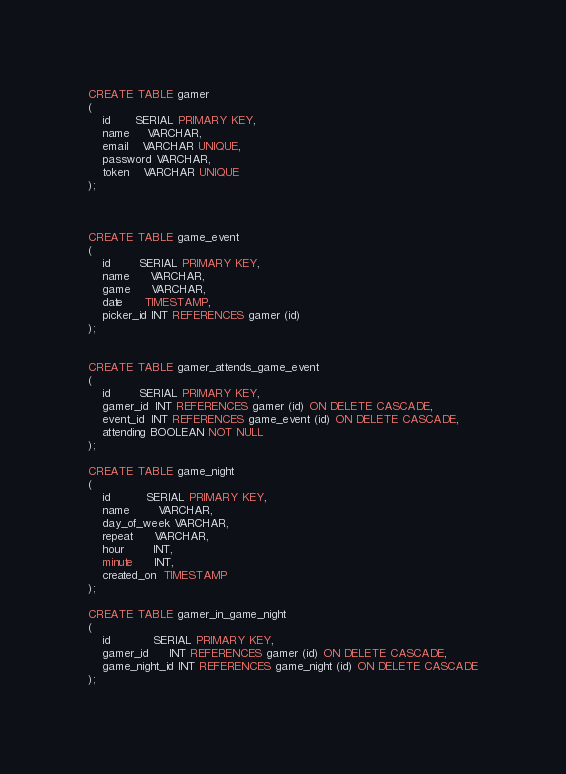<code> <loc_0><loc_0><loc_500><loc_500><_SQL_>CREATE TABLE gamer
(
    id       SERIAL PRIMARY KEY,
    name     VARCHAR,
    email    VARCHAR UNIQUE,
    password VARCHAR,
    token    VARCHAR UNIQUE
);



CREATE TABLE game_event
(
    id        SERIAL PRIMARY KEY,
    name      VARCHAR,
    game      VARCHAR,
    date      TIMESTAMP,
    picker_id INT REFERENCES gamer (id)
);


CREATE TABLE gamer_attends_game_event
(
    id        SERIAL PRIMARY KEY,
    gamer_id  INT REFERENCES gamer (id) ON DELETE CASCADE,
    event_id  INT REFERENCES game_event (id) ON DELETE CASCADE,
    attending BOOLEAN NOT NULL
);

CREATE TABLE game_night
(
    id          SERIAL PRIMARY KEY,
    name        VARCHAR,
    day_of_week VARCHAR,
    repeat      VARCHAR,
    hour        INT,
    minute      INT,
    created_on  TIMESTAMP
);

CREATE TABLE gamer_in_game_night
(
    id            SERIAL PRIMARY KEY,
    gamer_id      INT REFERENCES gamer (id) ON DELETE CASCADE,
    game_night_id INT REFERENCES game_night (id) ON DELETE CASCADE
);
</code> 